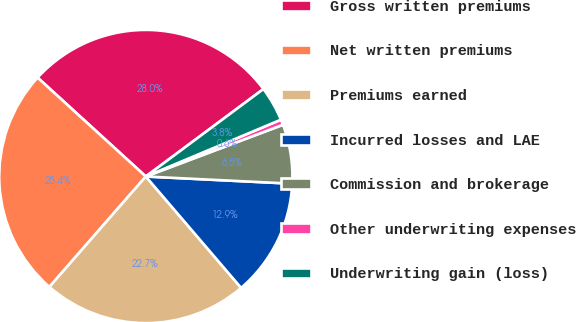<chart> <loc_0><loc_0><loc_500><loc_500><pie_chart><fcel>Gross written premiums<fcel>Net written premiums<fcel>Premiums earned<fcel>Incurred losses and LAE<fcel>Commission and brokerage<fcel>Other underwriting expenses<fcel>Underwriting gain (loss)<nl><fcel>28.04%<fcel>25.36%<fcel>22.69%<fcel>12.95%<fcel>6.52%<fcel>0.6%<fcel>3.84%<nl></chart> 